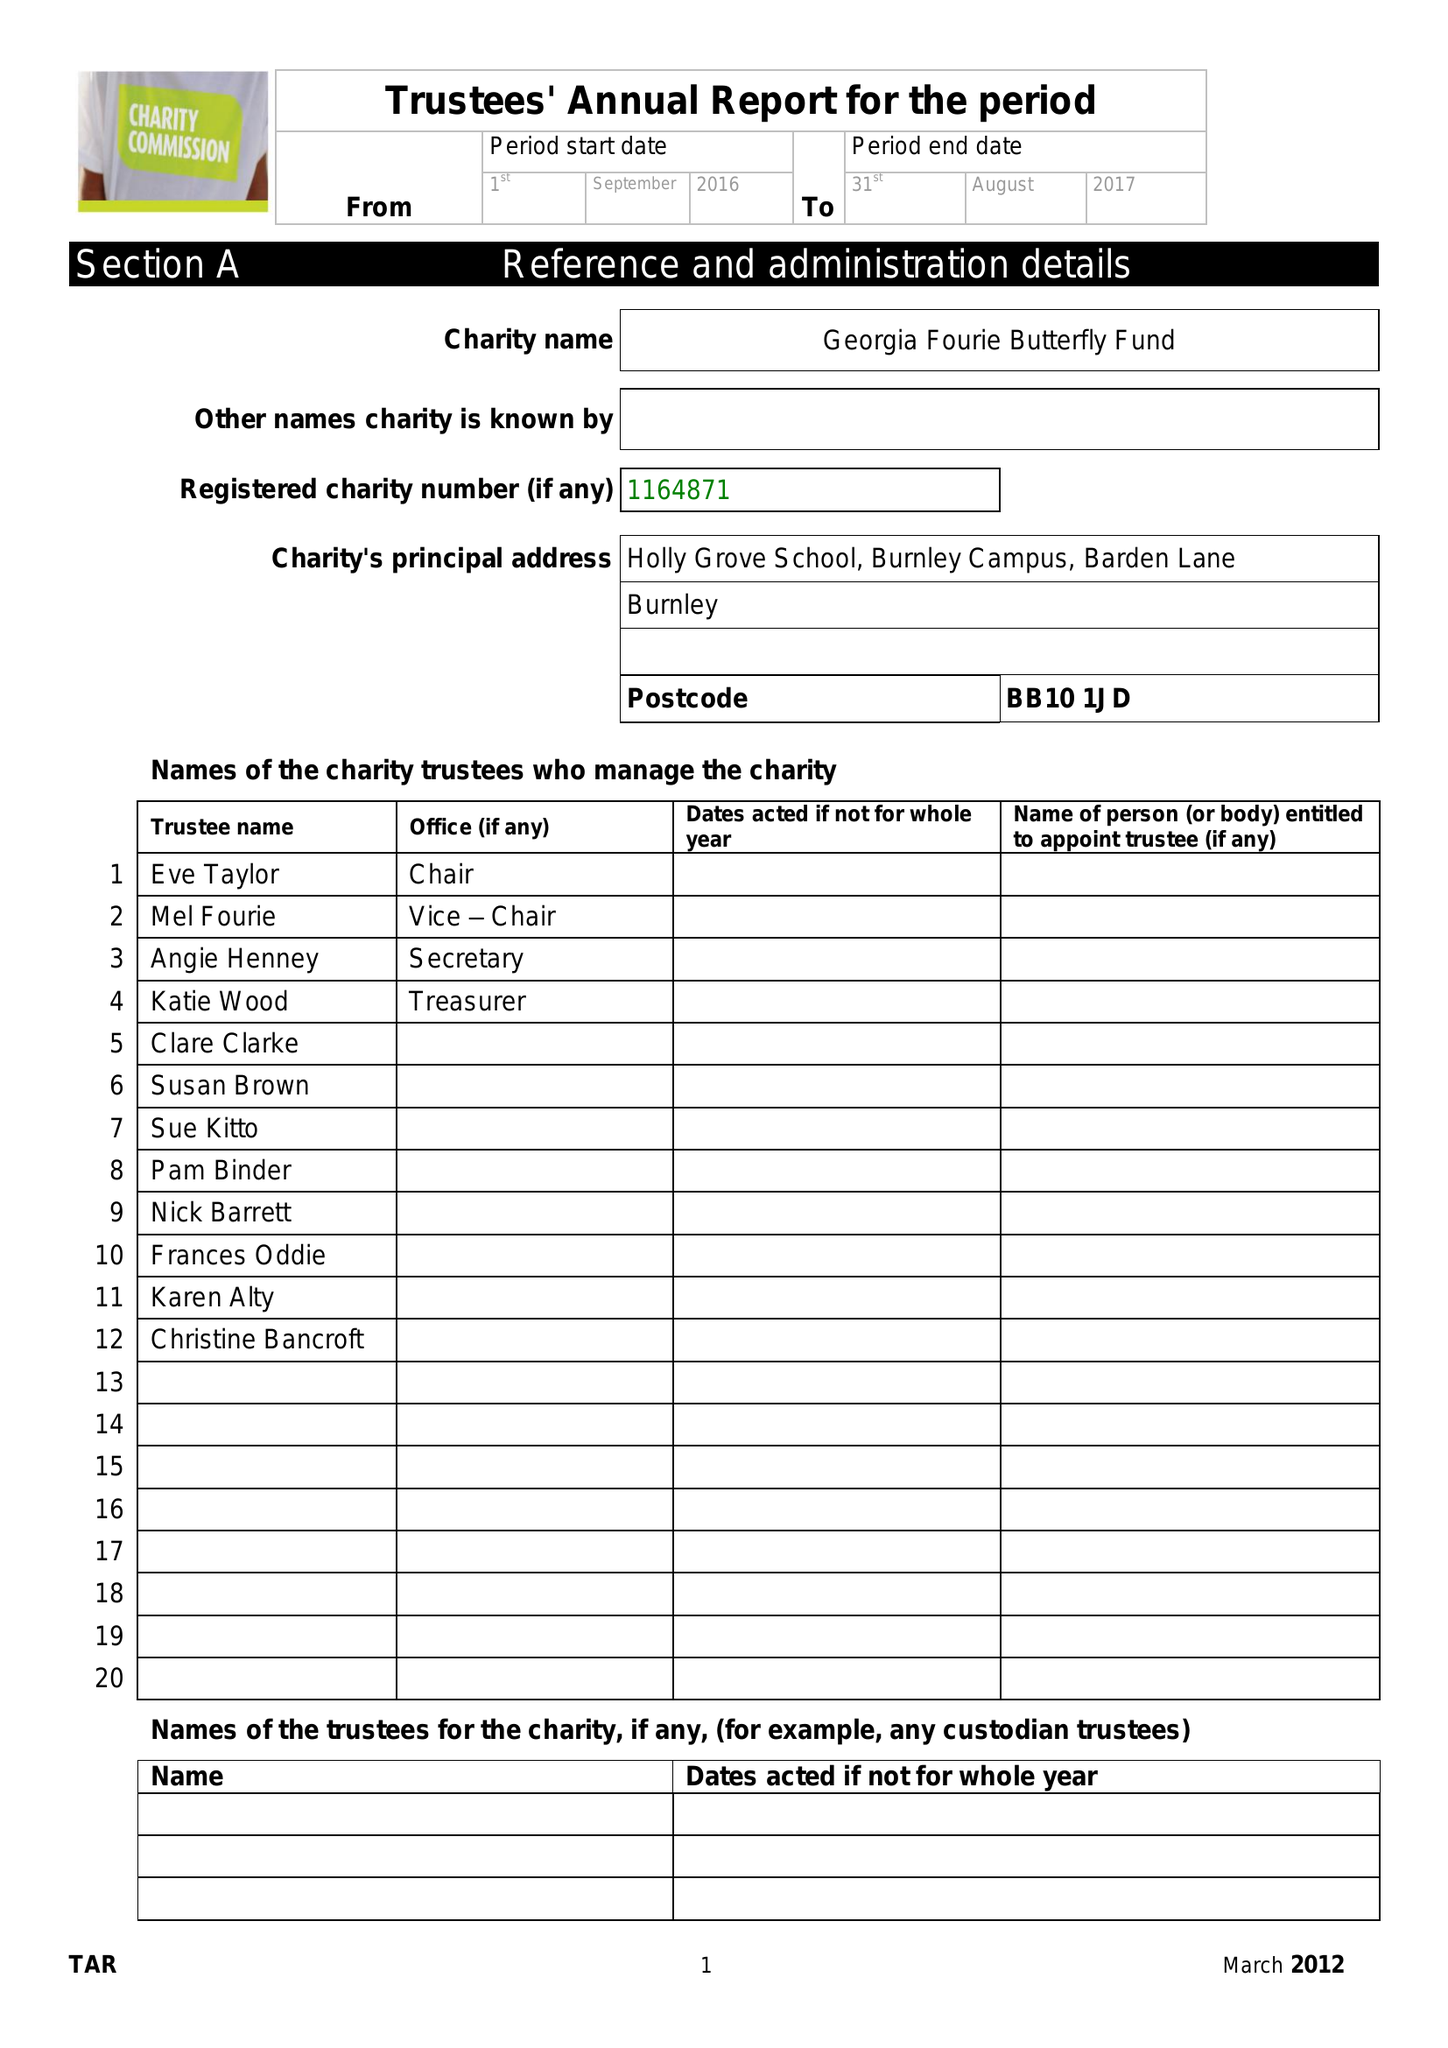What is the value for the address__post_town?
Answer the question using a single word or phrase. BURNLEY 